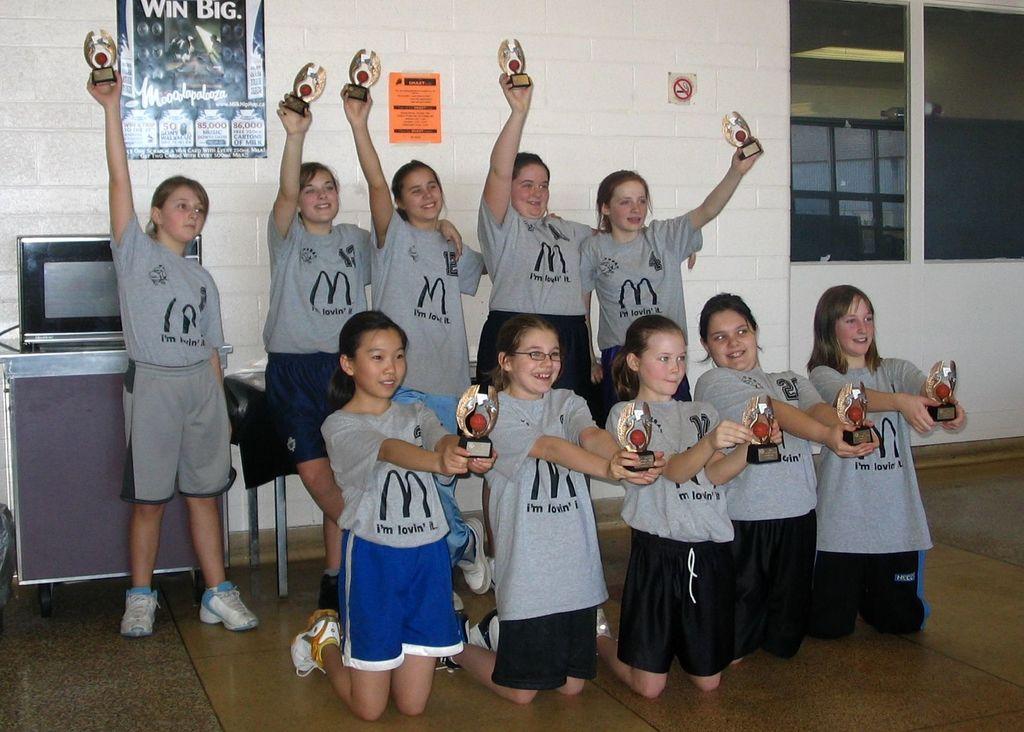Who is sponsoring the shirt?
Give a very brief answer. Mcdonalds. 